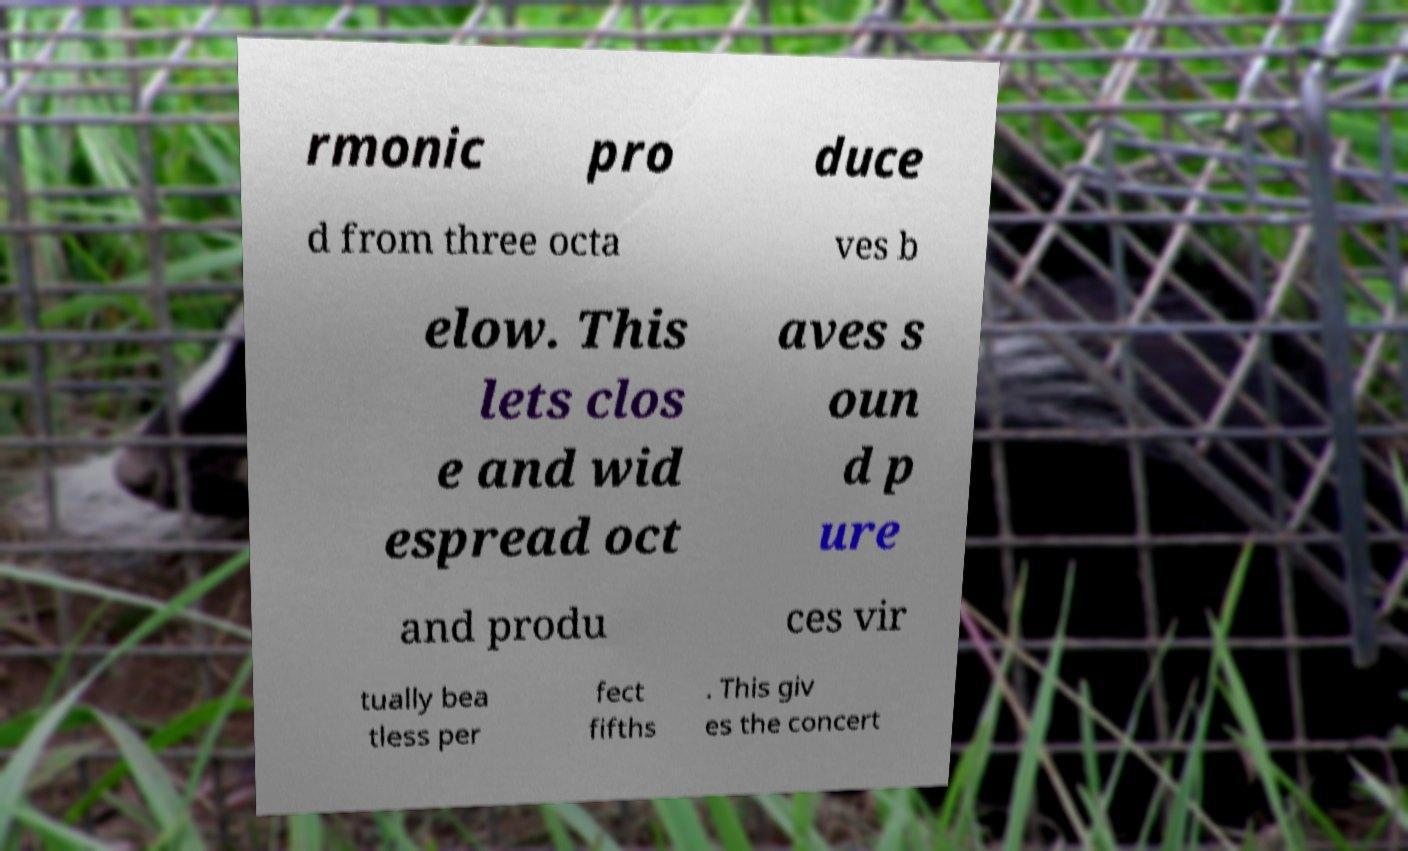Could you assist in decoding the text presented in this image and type it out clearly? rmonic pro duce d from three octa ves b elow. This lets clos e and wid espread oct aves s oun d p ure and produ ces vir tually bea tless per fect fifths . This giv es the concert 